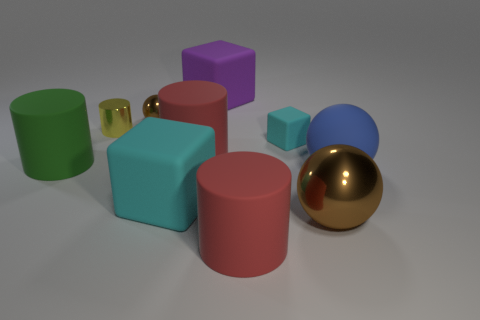Subtract all large blocks. How many blocks are left? 1 Subtract all green cylinders. How many brown balls are left? 2 Subtract 1 balls. How many balls are left? 2 Subtract all green cylinders. How many cylinders are left? 3 Subtract 0 purple cylinders. How many objects are left? 10 Subtract all spheres. How many objects are left? 7 Subtract all red cylinders. Subtract all blue cubes. How many cylinders are left? 2 Subtract all tiny yellow objects. Subtract all tiny yellow things. How many objects are left? 8 Add 6 large blue balls. How many large blue balls are left? 7 Add 5 tiny red cylinders. How many tiny red cylinders exist? 5 